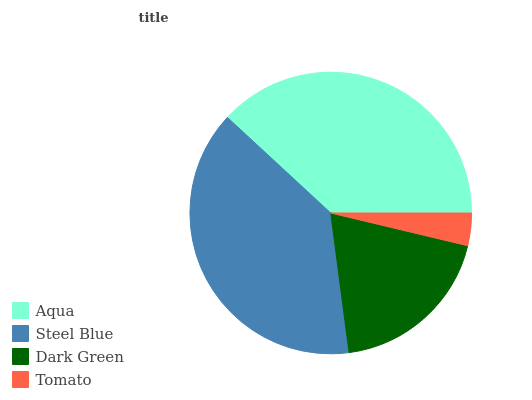Is Tomato the minimum?
Answer yes or no. Yes. Is Steel Blue the maximum?
Answer yes or no. Yes. Is Dark Green the minimum?
Answer yes or no. No. Is Dark Green the maximum?
Answer yes or no. No. Is Steel Blue greater than Dark Green?
Answer yes or no. Yes. Is Dark Green less than Steel Blue?
Answer yes or no. Yes. Is Dark Green greater than Steel Blue?
Answer yes or no. No. Is Steel Blue less than Dark Green?
Answer yes or no. No. Is Aqua the high median?
Answer yes or no. Yes. Is Dark Green the low median?
Answer yes or no. Yes. Is Steel Blue the high median?
Answer yes or no. No. Is Aqua the low median?
Answer yes or no. No. 